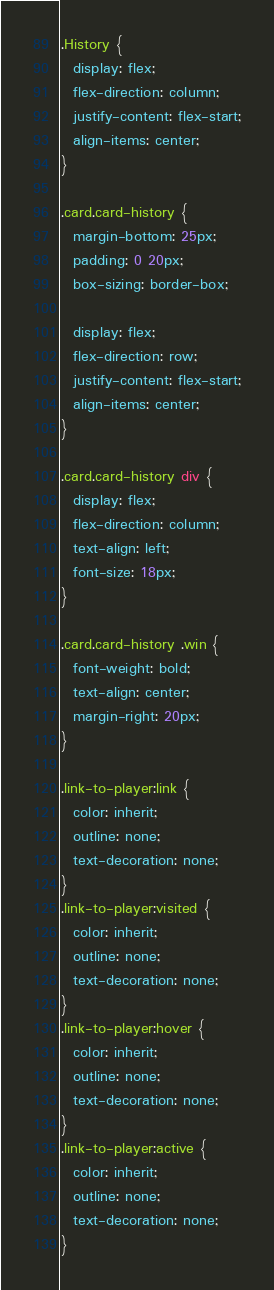<code> <loc_0><loc_0><loc_500><loc_500><_CSS_>.History {
  display: flex;
  flex-direction: column;
  justify-content: flex-start;
  align-items: center;
}

.card.card-history {
  margin-bottom: 25px;
  padding: 0 20px;
  box-sizing: border-box;

  display: flex;
  flex-direction: row;
  justify-content: flex-start;
  align-items: center;
}

.card.card-history div {
  display: flex;
  flex-direction: column;
  text-align: left;
  font-size: 18px;
}

.card.card-history .win {
  font-weight: bold;
  text-align: center;
  margin-right: 20px;
}

.link-to-player:link {
  color: inherit;
  outline: none;
  text-decoration: none;
}
.link-to-player:visited {
  color: inherit;
  outline: none;
  text-decoration: none;
}
.link-to-player:hover {
  color: inherit;
  outline: none;
  text-decoration: none;
}
.link-to-player:active {
  color: inherit;
  outline: none;
  text-decoration: none;
}
</code> 